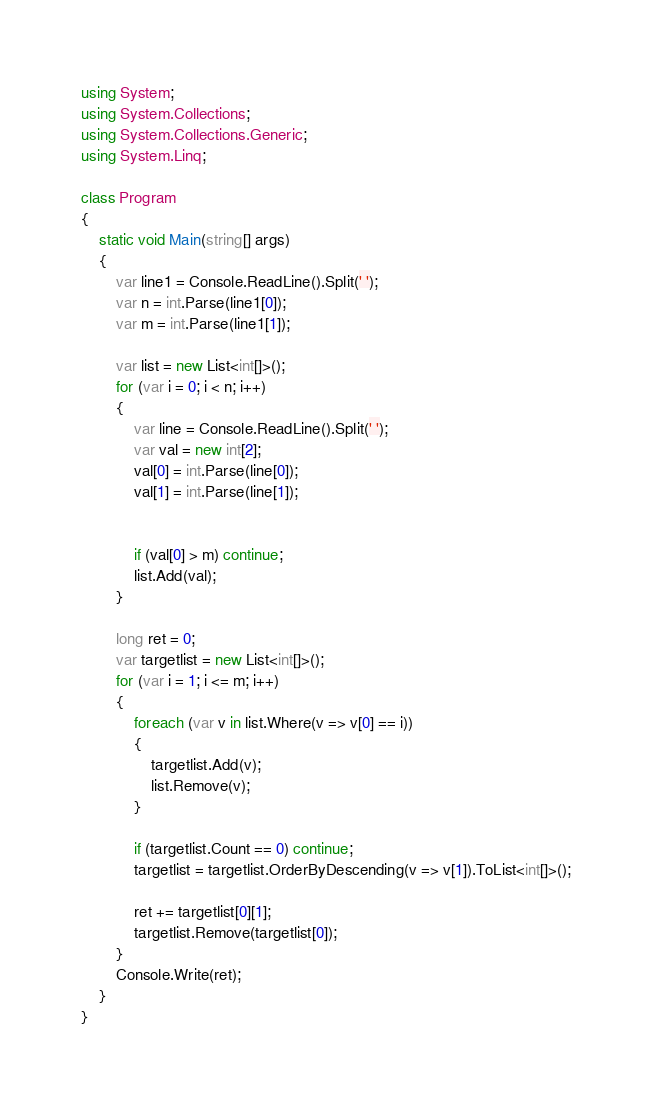<code> <loc_0><loc_0><loc_500><loc_500><_C#_>using System;
using System.Collections;
using System.Collections.Generic;
using System.Linq;

class Program
{
    static void Main(string[] args)
    {
        var line1 = Console.ReadLine().Split(' ');
        var n = int.Parse(line1[0]);
        var m = int.Parse(line1[1]);

        var list = new List<int[]>();
        for (var i = 0; i < n; i++)
        {
            var line = Console.ReadLine().Split(' ');
            var val = new int[2];
            val[0] = int.Parse(line[0]);
            val[1] = int.Parse(line[1]);


            if (val[0] > m) continue;
            list.Add(val);
        }

        long ret = 0;
        var targetlist = new List<int[]>();
        for (var i = 1; i <= m; i++)
        {
            foreach (var v in list.Where(v => v[0] == i))
            {
                targetlist.Add(v);
                list.Remove(v);
            }

            if (targetlist.Count == 0) continue;
            targetlist = targetlist.OrderByDescending(v => v[1]).ToList<int[]>();
        
            ret += targetlist[0][1];
            targetlist.Remove(targetlist[0]);
        }
        Console.Write(ret);
    }
}
</code> 